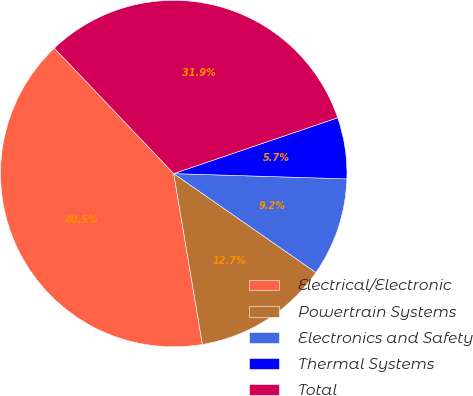Convert chart to OTSL. <chart><loc_0><loc_0><loc_500><loc_500><pie_chart><fcel>Electrical/Electronic<fcel>Powertrain Systems<fcel>Electronics and Safety<fcel>Thermal Systems<fcel>Total<nl><fcel>40.54%<fcel>12.68%<fcel>9.19%<fcel>5.71%<fcel>31.88%<nl></chart> 